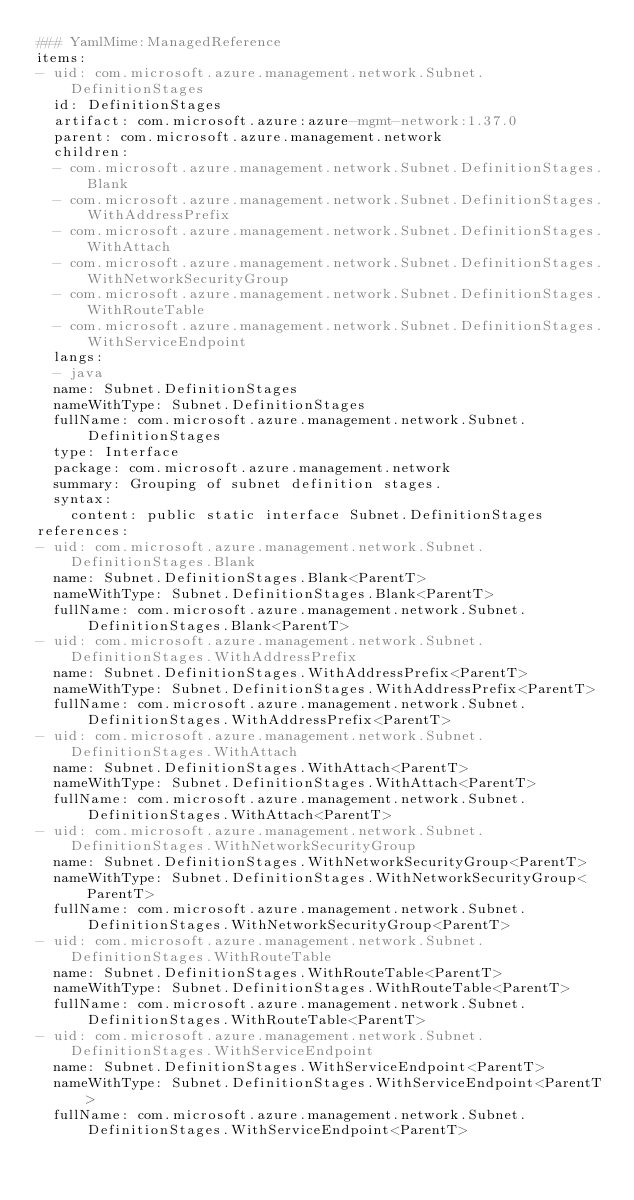<code> <loc_0><loc_0><loc_500><loc_500><_YAML_>### YamlMime:ManagedReference
items:
- uid: com.microsoft.azure.management.network.Subnet.DefinitionStages
  id: DefinitionStages
  artifact: com.microsoft.azure:azure-mgmt-network:1.37.0
  parent: com.microsoft.azure.management.network
  children:
  - com.microsoft.azure.management.network.Subnet.DefinitionStages.Blank
  - com.microsoft.azure.management.network.Subnet.DefinitionStages.WithAddressPrefix
  - com.microsoft.azure.management.network.Subnet.DefinitionStages.WithAttach
  - com.microsoft.azure.management.network.Subnet.DefinitionStages.WithNetworkSecurityGroup
  - com.microsoft.azure.management.network.Subnet.DefinitionStages.WithRouteTable
  - com.microsoft.azure.management.network.Subnet.DefinitionStages.WithServiceEndpoint
  langs:
  - java
  name: Subnet.DefinitionStages
  nameWithType: Subnet.DefinitionStages
  fullName: com.microsoft.azure.management.network.Subnet.DefinitionStages
  type: Interface
  package: com.microsoft.azure.management.network
  summary: Grouping of subnet definition stages.
  syntax:
    content: public static interface Subnet.DefinitionStages
references:
- uid: com.microsoft.azure.management.network.Subnet.DefinitionStages.Blank
  name: Subnet.DefinitionStages.Blank<ParentT>
  nameWithType: Subnet.DefinitionStages.Blank<ParentT>
  fullName: com.microsoft.azure.management.network.Subnet.DefinitionStages.Blank<ParentT>
- uid: com.microsoft.azure.management.network.Subnet.DefinitionStages.WithAddressPrefix
  name: Subnet.DefinitionStages.WithAddressPrefix<ParentT>
  nameWithType: Subnet.DefinitionStages.WithAddressPrefix<ParentT>
  fullName: com.microsoft.azure.management.network.Subnet.DefinitionStages.WithAddressPrefix<ParentT>
- uid: com.microsoft.azure.management.network.Subnet.DefinitionStages.WithAttach
  name: Subnet.DefinitionStages.WithAttach<ParentT>
  nameWithType: Subnet.DefinitionStages.WithAttach<ParentT>
  fullName: com.microsoft.azure.management.network.Subnet.DefinitionStages.WithAttach<ParentT>
- uid: com.microsoft.azure.management.network.Subnet.DefinitionStages.WithNetworkSecurityGroup
  name: Subnet.DefinitionStages.WithNetworkSecurityGroup<ParentT>
  nameWithType: Subnet.DefinitionStages.WithNetworkSecurityGroup<ParentT>
  fullName: com.microsoft.azure.management.network.Subnet.DefinitionStages.WithNetworkSecurityGroup<ParentT>
- uid: com.microsoft.azure.management.network.Subnet.DefinitionStages.WithRouteTable
  name: Subnet.DefinitionStages.WithRouteTable<ParentT>
  nameWithType: Subnet.DefinitionStages.WithRouteTable<ParentT>
  fullName: com.microsoft.azure.management.network.Subnet.DefinitionStages.WithRouteTable<ParentT>
- uid: com.microsoft.azure.management.network.Subnet.DefinitionStages.WithServiceEndpoint
  name: Subnet.DefinitionStages.WithServiceEndpoint<ParentT>
  nameWithType: Subnet.DefinitionStages.WithServiceEndpoint<ParentT>
  fullName: com.microsoft.azure.management.network.Subnet.DefinitionStages.WithServiceEndpoint<ParentT>
</code> 